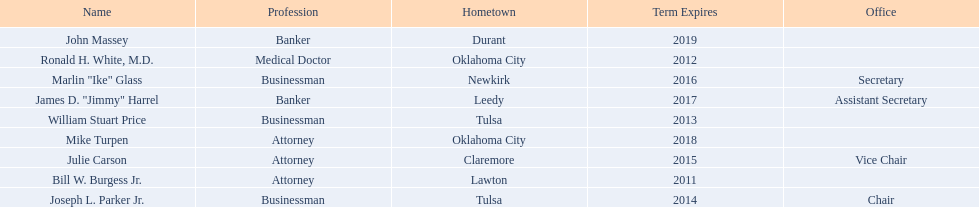What are the names of the oklahoma state regents for higher education? Bill W. Burgess Jr., Ronald H. White, M.D., William Stuart Price, Joseph L. Parker Jr., Julie Carson, Marlin "Ike" Glass, James D. "Jimmy" Harrel, Mike Turpen, John Massey. What is ronald h. white's hometown? Oklahoma City. Which other regent has the same hometown as above? Mike Turpen. 